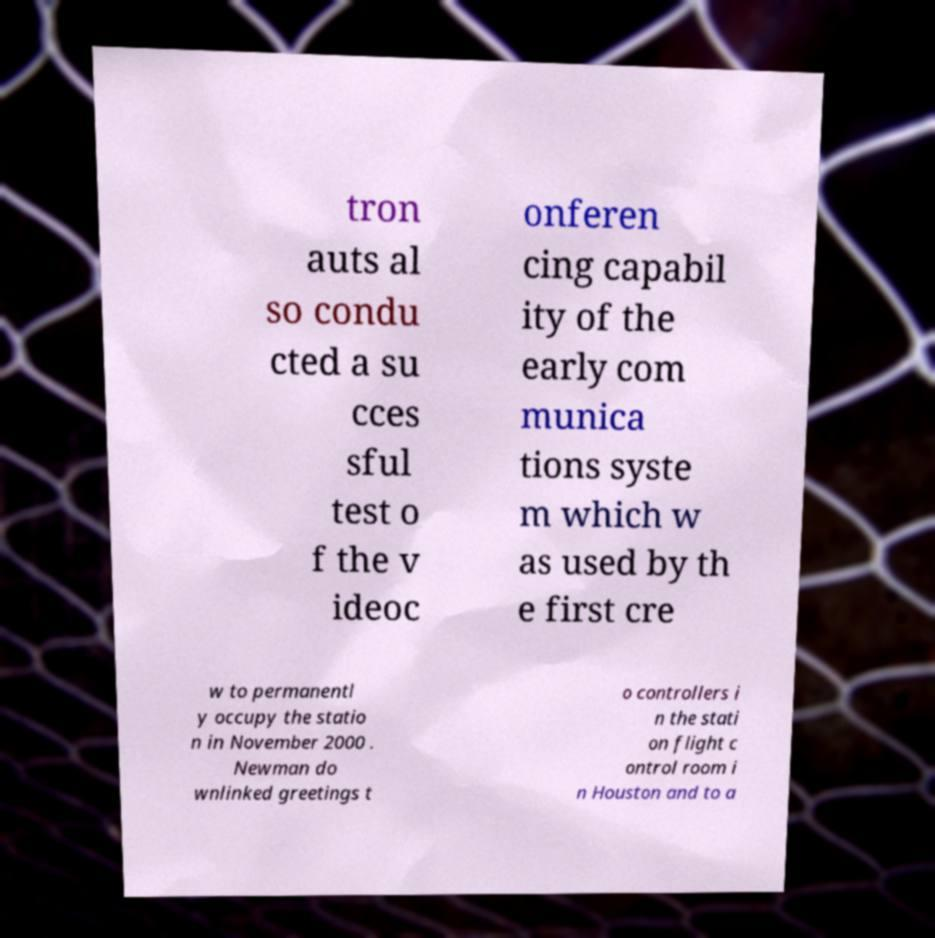For documentation purposes, I need the text within this image transcribed. Could you provide that? tron auts al so condu cted a su cces sful test o f the v ideoc onferen cing capabil ity of the early com munica tions syste m which w as used by th e first cre w to permanentl y occupy the statio n in November 2000 . Newman do wnlinked greetings t o controllers i n the stati on flight c ontrol room i n Houston and to a 